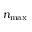Convert formula to latex. <formula><loc_0><loc_0><loc_500><loc_500>n _ { \max }</formula> 